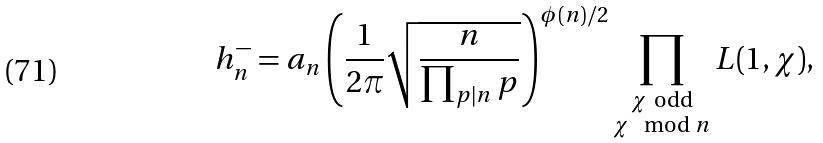<formula> <loc_0><loc_0><loc_500><loc_500>h _ { n } ^ { - } = a _ { n } \left ( \frac { 1 } { 2 \pi } \sqrt { \frac { n } { \prod _ { p | n } p } } \right ) ^ { \phi ( n ) / 2 } \prod _ { \substack { \chi \ \text {odd} \\ \chi \mod n } } L ( 1 , \chi ) ,</formula> 